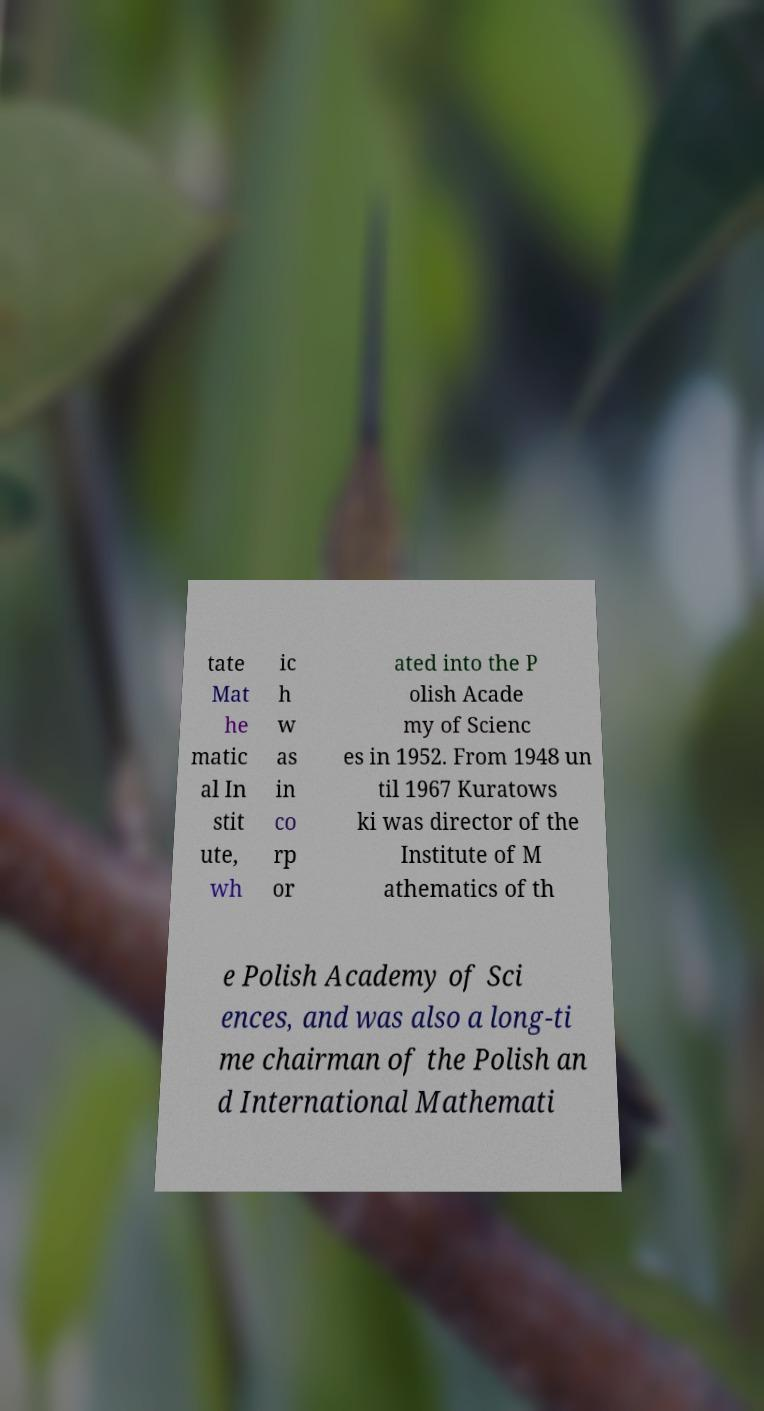Please read and relay the text visible in this image. What does it say? tate Mat he matic al In stit ute, wh ic h w as in co rp or ated into the P olish Acade my of Scienc es in 1952. From 1948 un til 1967 Kuratows ki was director of the Institute of M athematics of th e Polish Academy of Sci ences, and was also a long-ti me chairman of the Polish an d International Mathemati 